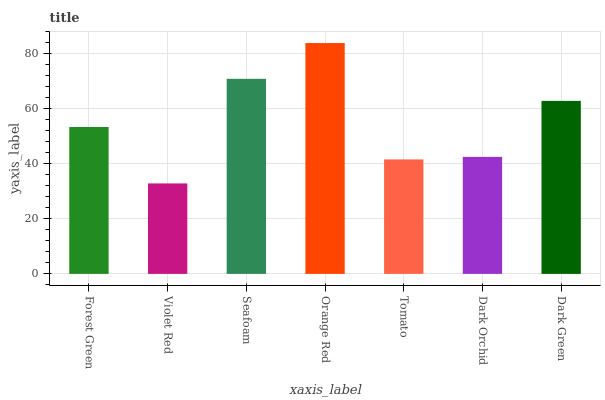Is Violet Red the minimum?
Answer yes or no. Yes. Is Orange Red the maximum?
Answer yes or no. Yes. Is Seafoam the minimum?
Answer yes or no. No. Is Seafoam the maximum?
Answer yes or no. No. Is Seafoam greater than Violet Red?
Answer yes or no. Yes. Is Violet Red less than Seafoam?
Answer yes or no. Yes. Is Violet Red greater than Seafoam?
Answer yes or no. No. Is Seafoam less than Violet Red?
Answer yes or no. No. Is Forest Green the high median?
Answer yes or no. Yes. Is Forest Green the low median?
Answer yes or no. Yes. Is Tomato the high median?
Answer yes or no. No. Is Violet Red the low median?
Answer yes or no. No. 